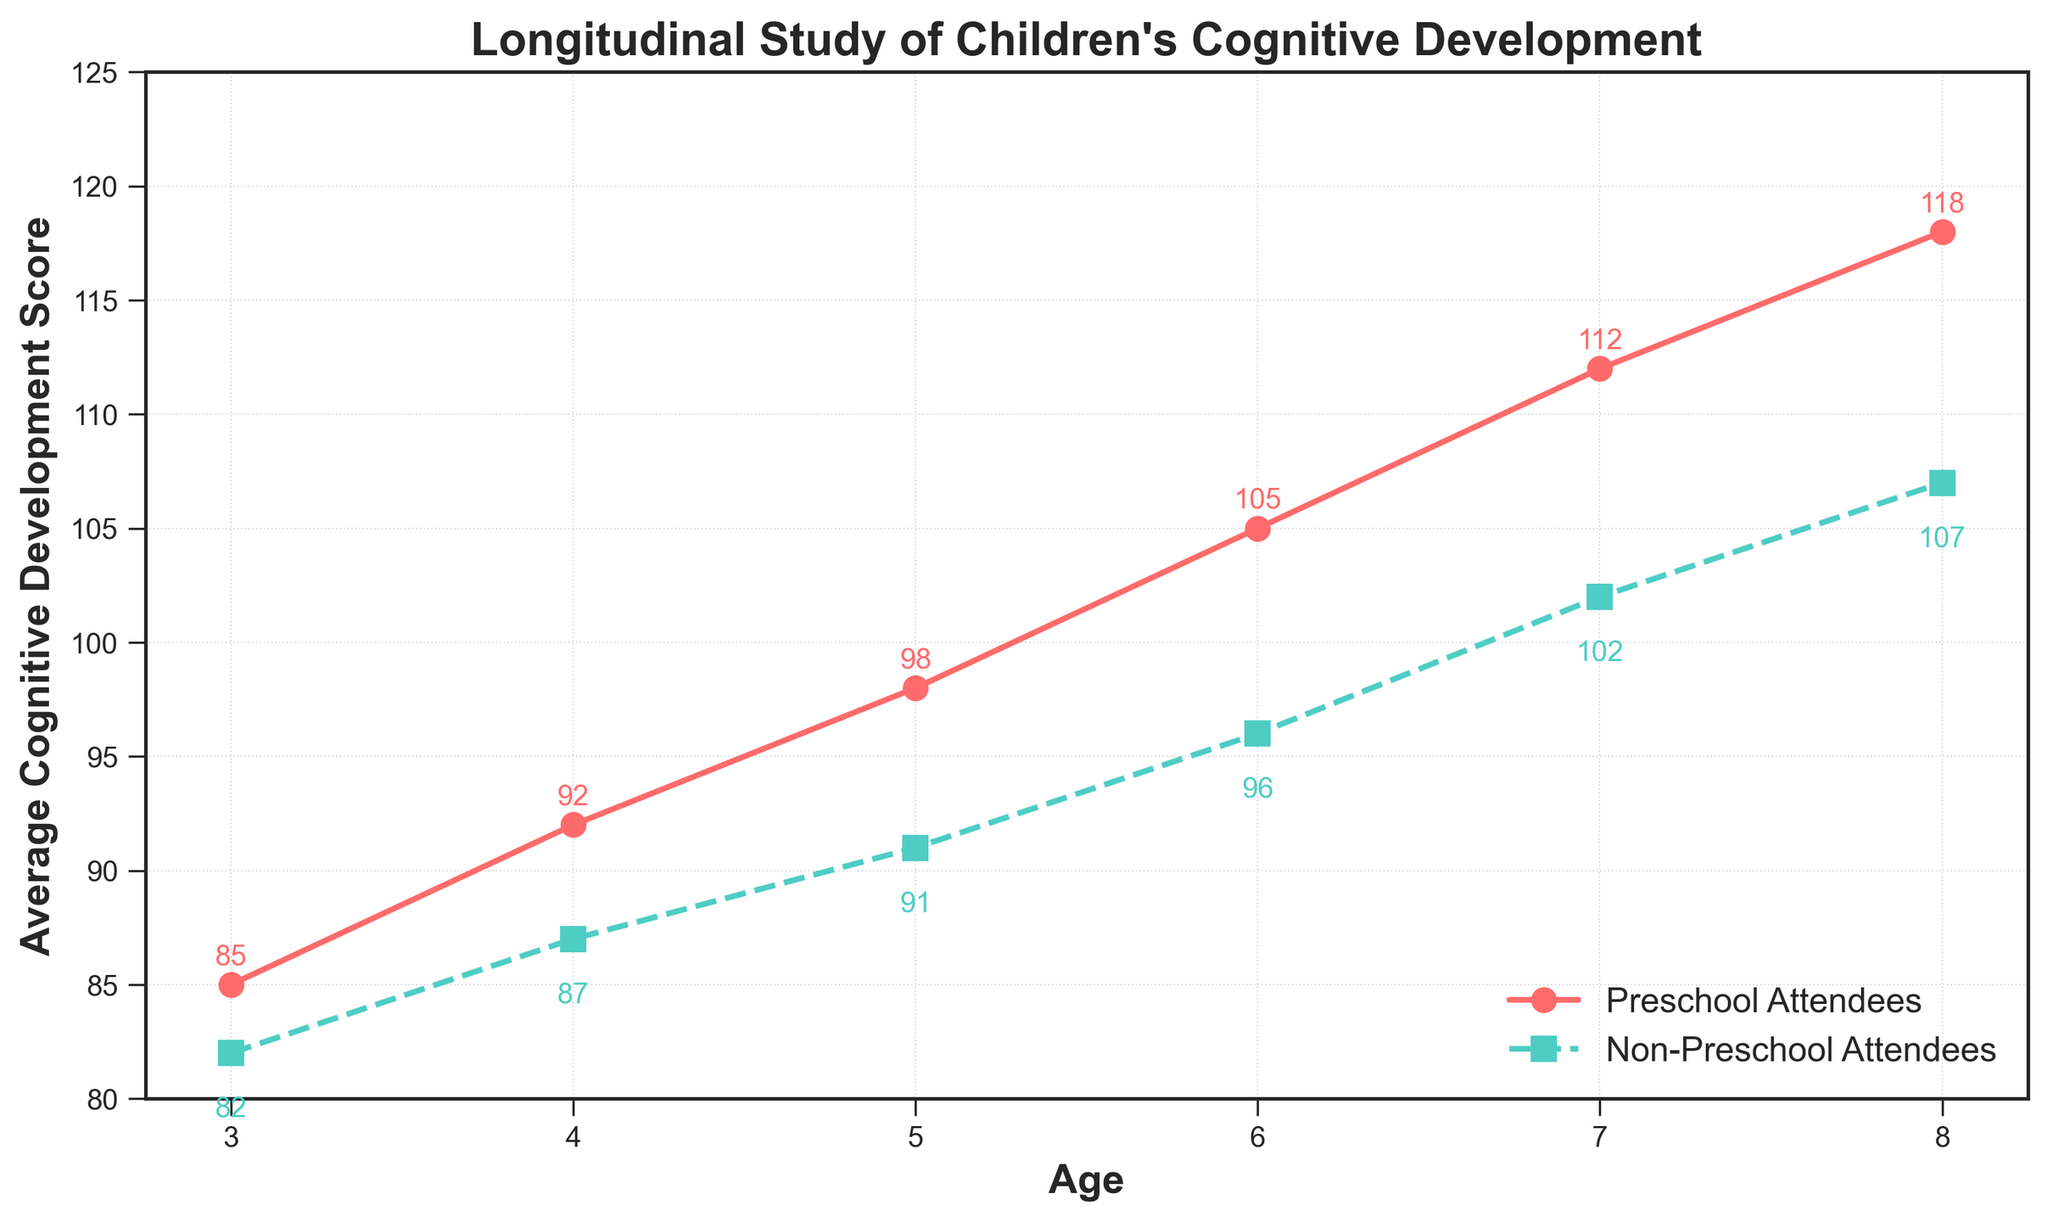What's the difference in cognitive development scores at age 6 between preschool attendees and non-preschool attendees? At age 6, the score for preschool attendees is 105 and for non-preschool attendees is 96. The difference is calculated as 105 - 96
Answer: 9 Which group shows a higher cognitive development score consistently across all ages? By observing the lines on the chart, the cognitive development scores of preschool attendees are consistently higher than those of non-preschool attendees at all ages
Answer: Preschool attendees At which age is the difference in cognitive development scores the smallest between the two groups? Examining the chart, the smallest difference appears at age 3 with the scores of 85 for preschool attendees and 82 for non-preschool attendees. The difference is 85 - 82
Answer: Age 3 What is the average cognitive development score of preschool attendees from ages 3 to 8? Sum the scores of preschool attendees (85 + 92 + 98 + 105 + 112 + 118) which equals 610. Divide this by the total number of ages, which is 6. Therefore, 610/6
Answer: 101.67 How much higher is the cognitive development score of preschool attendees compared to non-preschool attendees at age 8? At age 8, the scores are 118 for preschool attendees and 107 for non-preschool attendees. The difference is 118 - 107
Answer: 11 By how much does the cognitive development score of preschool attendees increase from age 3 to age 8? The score at age 3 is 85 and at age 8 is 118. The increase is calculated as 118 - 85
Answer: 33 Which age shows the highest cognitive development score for non-preschool attendees? Looking at the chart, the highest score for non-preschool attendees is at age 8 with a score of 107
Answer: Age 8 What is the trend of cognitive development scores for both groups as they age from 3 to 8? From age 3 to 8, both groups show an increasing trend in cognitive development scores, with the scores steadily rising as the ages increase
Answer: Increasing trend 